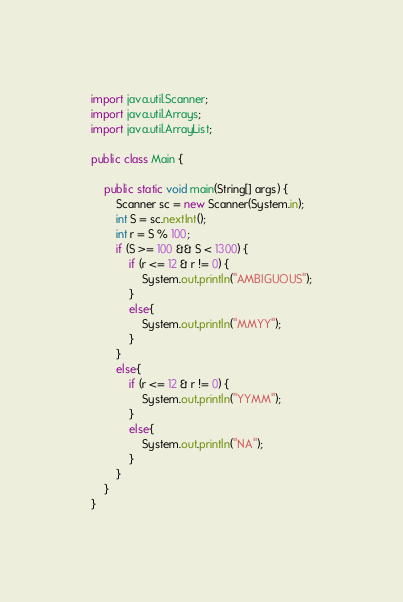<code> <loc_0><loc_0><loc_500><loc_500><_Java_>import java.util.Scanner;
import java.util.Arrays;
import java.util.ArrayList;

public class Main {

    public static void main(String[] args) {
        Scanner sc = new Scanner(System.in);
        int S = sc.nextInt();
        int r = S % 100;
        if (S >= 100 && S < 1300) {
            if (r <= 12 & r != 0) {
                System.out.println("AMBIGUOUS");
            }
            else{
                System.out.println("MMYY");
            }
        }
        else{
            if (r <= 12 & r != 0) {
                System.out.println("YYMM");
            }
            else{
                System.out.println("NA");
            }
        }
    }
}

</code> 